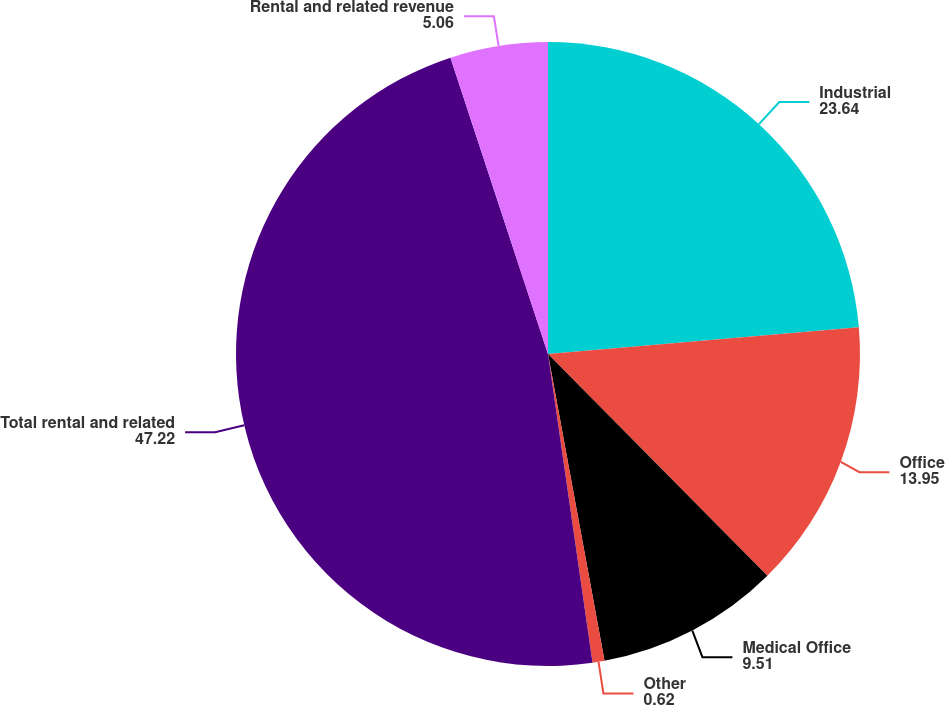Convert chart. <chart><loc_0><loc_0><loc_500><loc_500><pie_chart><fcel>Industrial<fcel>Office<fcel>Medical Office<fcel>Other<fcel>Total rental and related<fcel>Rental and related revenue<nl><fcel>23.64%<fcel>13.95%<fcel>9.51%<fcel>0.62%<fcel>47.22%<fcel>5.06%<nl></chart> 